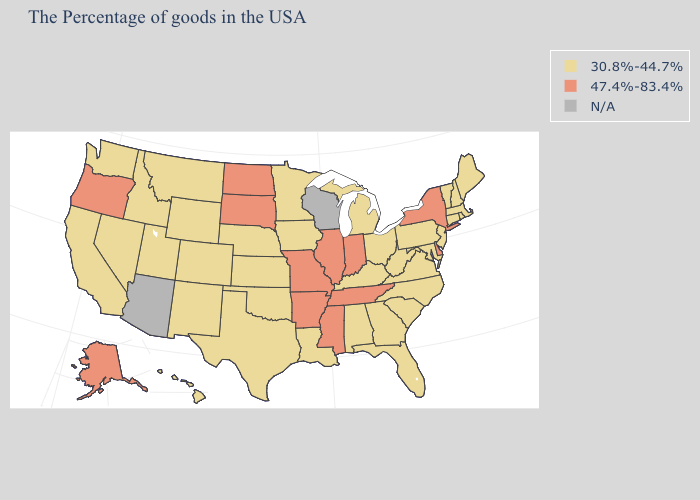What is the highest value in states that border Ohio?
Answer briefly. 47.4%-83.4%. Does the first symbol in the legend represent the smallest category?
Answer briefly. Yes. Name the states that have a value in the range 30.8%-44.7%?
Answer briefly. Maine, Massachusetts, Rhode Island, New Hampshire, Vermont, Connecticut, New Jersey, Maryland, Pennsylvania, Virginia, North Carolina, South Carolina, West Virginia, Ohio, Florida, Georgia, Michigan, Kentucky, Alabama, Louisiana, Minnesota, Iowa, Kansas, Nebraska, Oklahoma, Texas, Wyoming, Colorado, New Mexico, Utah, Montana, Idaho, Nevada, California, Washington, Hawaii. What is the value of Kansas?
Write a very short answer. 30.8%-44.7%. Does Oregon have the highest value in the USA?
Concise answer only. Yes. Name the states that have a value in the range 30.8%-44.7%?
Short answer required. Maine, Massachusetts, Rhode Island, New Hampshire, Vermont, Connecticut, New Jersey, Maryland, Pennsylvania, Virginia, North Carolina, South Carolina, West Virginia, Ohio, Florida, Georgia, Michigan, Kentucky, Alabama, Louisiana, Minnesota, Iowa, Kansas, Nebraska, Oklahoma, Texas, Wyoming, Colorado, New Mexico, Utah, Montana, Idaho, Nevada, California, Washington, Hawaii. Does Kentucky have the lowest value in the USA?
Write a very short answer. Yes. How many symbols are there in the legend?
Quick response, please. 3. Name the states that have a value in the range N/A?
Give a very brief answer. Wisconsin, Arizona. What is the value of Utah?
Answer briefly. 30.8%-44.7%. Among the states that border Alabama , does Georgia have the highest value?
Short answer required. No. Which states have the lowest value in the West?
Answer briefly. Wyoming, Colorado, New Mexico, Utah, Montana, Idaho, Nevada, California, Washington, Hawaii. Name the states that have a value in the range 47.4%-83.4%?
Be succinct. New York, Delaware, Indiana, Tennessee, Illinois, Mississippi, Missouri, Arkansas, South Dakota, North Dakota, Oregon, Alaska. What is the value of Nevada?
Concise answer only. 30.8%-44.7%. 